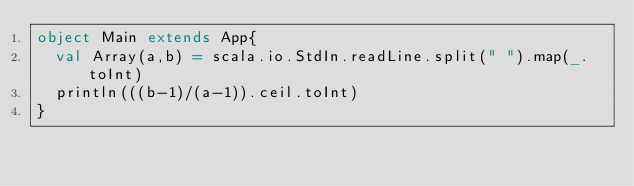<code> <loc_0><loc_0><loc_500><loc_500><_Scala_>object Main extends App{
  val Array(a,b) = scala.io.StdIn.readLine.split(" ").map(_.toInt)
  println(((b-1)/(a-1)).ceil.toInt)
}
</code> 